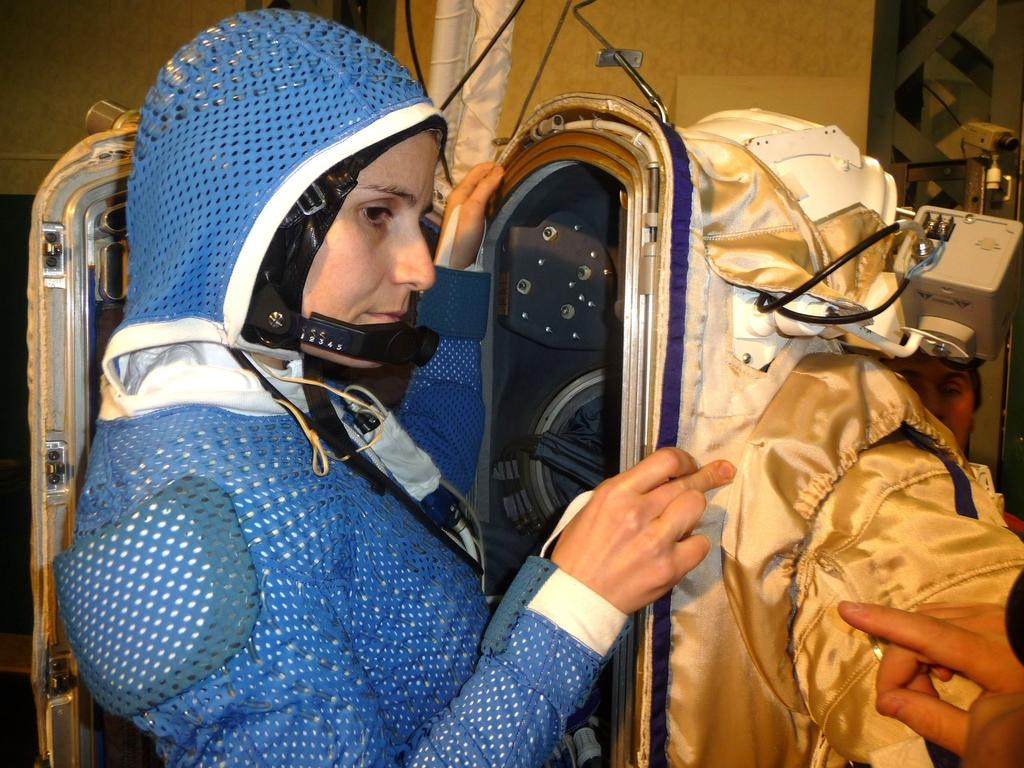Who is present in the image? There is a woman in the image. What is the woman wearing? The woman is wearing a blue dress. Where is the woman located in the image? The woman is standing near a door. What else can be seen in the image besides the woman? Clothes are visible in the image. Can you describe the hand in the bottom right corner of the image? There is a person's hand in the bottom right corner of the image. How many houses are visible in the image? There are no houses visible in the image. What type of pies is the woman holding in the image? There are no pies present in the image. 